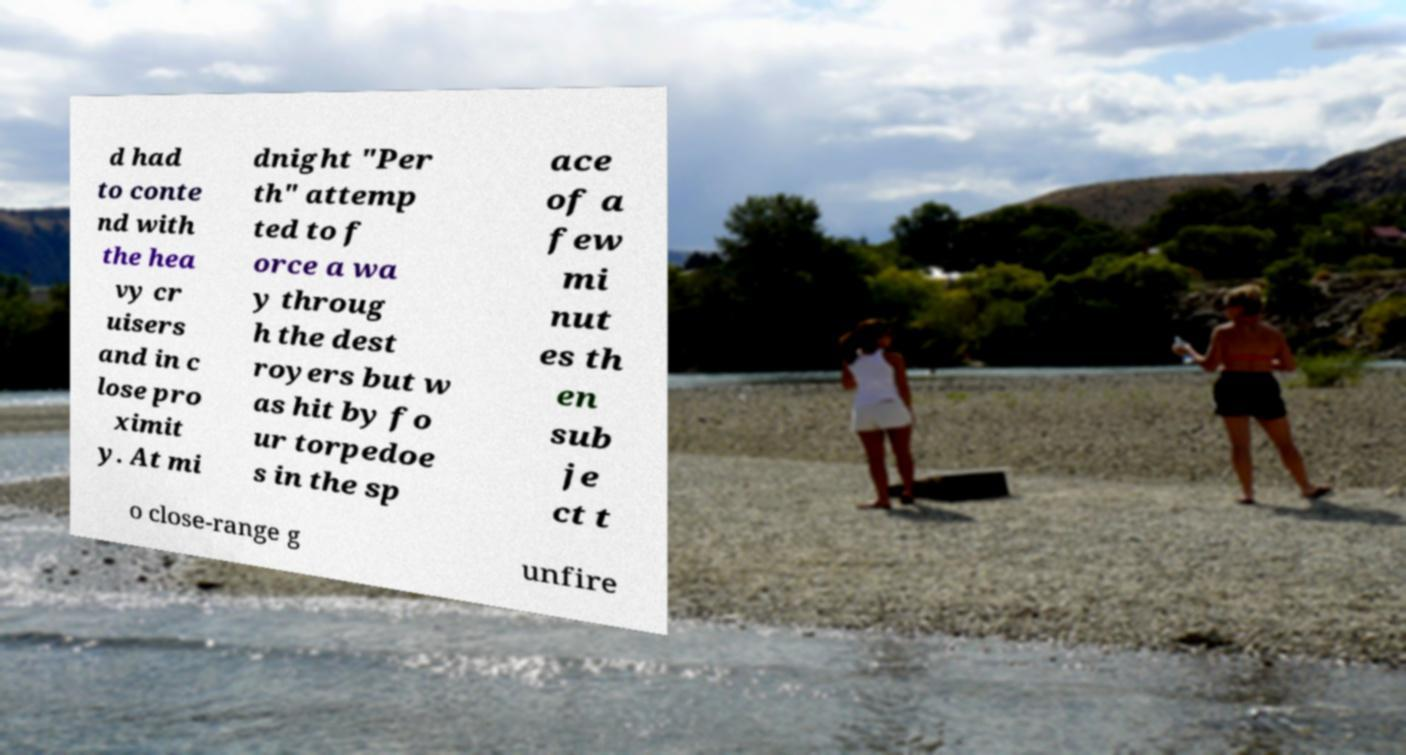I need the written content from this picture converted into text. Can you do that? d had to conte nd with the hea vy cr uisers and in c lose pro ximit y. At mi dnight "Per th" attemp ted to f orce a wa y throug h the dest royers but w as hit by fo ur torpedoe s in the sp ace of a few mi nut es th en sub je ct t o close-range g unfire 